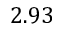Convert formula to latex. <formula><loc_0><loc_0><loc_500><loc_500>2 . 9 3</formula> 